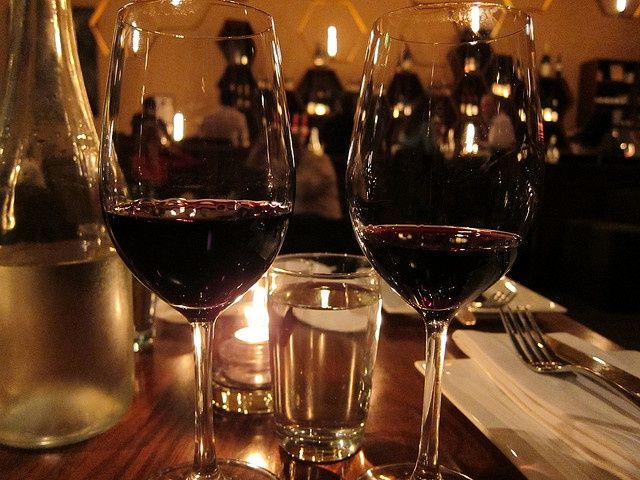Describe the objects in this image and their specific colors. I can see wine glass in maroon, black, and brown tones, wine glass in maroon, black, and brown tones, bottle in maroon, black, and olive tones, dining table in maroon, black, brown, and tan tones, and cup in maroon, brown, and tan tones in this image. 